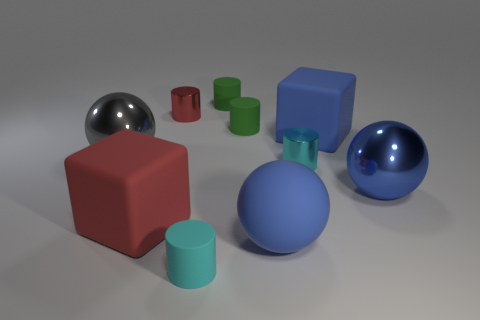What is the material of the other sphere that is the same color as the large matte sphere?
Provide a succinct answer. Metal. What number of big matte blocks have the same color as the matte ball?
Make the answer very short. 1. Is there another rubber object of the same shape as the tiny cyan matte thing?
Make the answer very short. Yes. Does the big matte object that is behind the red cube have the same color as the large metal object that is in front of the cyan metallic thing?
Your response must be concise. Yes. Are there any big blue objects in front of the small cyan shiny thing?
Provide a short and direct response. Yes. There is a big sphere that is right of the big red block and to the left of the big blue block; what material is it?
Offer a terse response. Rubber. Does the large cube that is behind the red cube have the same material as the red cube?
Your response must be concise. Yes. What is the blue cube made of?
Provide a short and direct response. Rubber. How big is the metallic cylinder to the left of the large blue matte sphere?
Your response must be concise. Small. There is a big rubber block that is in front of the shiny sphere that is on the right side of the small cyan matte thing; are there any small objects that are in front of it?
Your answer should be compact. Yes. 